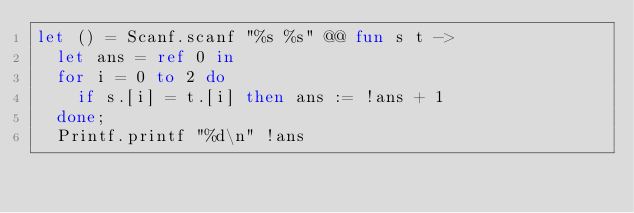<code> <loc_0><loc_0><loc_500><loc_500><_OCaml_>let () = Scanf.scanf "%s %s" @@ fun s t ->
  let ans = ref 0 in
  for i = 0 to 2 do
    if s.[i] = t.[i] then ans := !ans + 1
  done;
  Printf.printf "%d\n" !ans</code> 